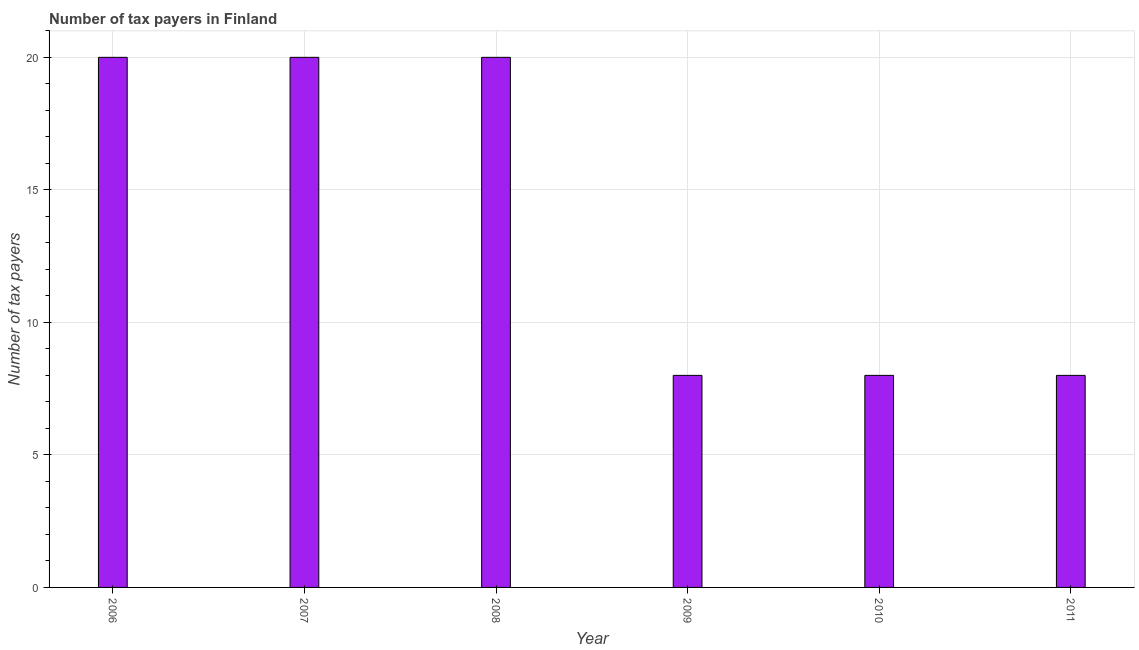Does the graph contain grids?
Your answer should be compact. Yes. What is the title of the graph?
Offer a terse response. Number of tax payers in Finland. What is the label or title of the X-axis?
Your answer should be very brief. Year. What is the label or title of the Y-axis?
Your answer should be very brief. Number of tax payers. Across all years, what is the maximum number of tax payers?
Offer a terse response. 20. Across all years, what is the minimum number of tax payers?
Your answer should be very brief. 8. In which year was the number of tax payers maximum?
Give a very brief answer. 2006. In which year was the number of tax payers minimum?
Your answer should be compact. 2009. What is the sum of the number of tax payers?
Provide a short and direct response. 84. What is the average number of tax payers per year?
Provide a succinct answer. 14. In how many years, is the number of tax payers greater than 17 ?
Give a very brief answer. 3. Do a majority of the years between 2007 and 2010 (inclusive) have number of tax payers greater than 10 ?
Offer a very short reply. No. What is the ratio of the number of tax payers in 2007 to that in 2009?
Your answer should be compact. 2.5. Is the number of tax payers in 2009 less than that in 2010?
Ensure brevity in your answer.  No. Is the difference between the number of tax payers in 2009 and 2011 greater than the difference between any two years?
Your answer should be compact. No. What is the difference between the highest and the second highest number of tax payers?
Provide a succinct answer. 0. Is the sum of the number of tax payers in 2008 and 2009 greater than the maximum number of tax payers across all years?
Provide a succinct answer. Yes. In how many years, is the number of tax payers greater than the average number of tax payers taken over all years?
Provide a short and direct response. 3. Are all the bars in the graph horizontal?
Keep it short and to the point. No. How many years are there in the graph?
Provide a succinct answer. 6. What is the difference between two consecutive major ticks on the Y-axis?
Offer a terse response. 5. Are the values on the major ticks of Y-axis written in scientific E-notation?
Give a very brief answer. No. What is the Number of tax payers of 2006?
Keep it short and to the point. 20. What is the Number of tax payers of 2008?
Make the answer very short. 20. What is the Number of tax payers of 2009?
Make the answer very short. 8. What is the Number of tax payers in 2011?
Offer a terse response. 8. What is the difference between the Number of tax payers in 2006 and 2008?
Offer a very short reply. 0. What is the difference between the Number of tax payers in 2006 and 2009?
Provide a short and direct response. 12. What is the difference between the Number of tax payers in 2007 and 2008?
Provide a short and direct response. 0. What is the difference between the Number of tax payers in 2007 and 2010?
Ensure brevity in your answer.  12. What is the difference between the Number of tax payers in 2008 and 2009?
Provide a succinct answer. 12. What is the difference between the Number of tax payers in 2008 and 2010?
Make the answer very short. 12. What is the difference between the Number of tax payers in 2009 and 2010?
Your answer should be compact. 0. What is the difference between the Number of tax payers in 2010 and 2011?
Give a very brief answer. 0. What is the ratio of the Number of tax payers in 2006 to that in 2007?
Ensure brevity in your answer.  1. What is the ratio of the Number of tax payers in 2007 to that in 2008?
Give a very brief answer. 1. What is the ratio of the Number of tax payers in 2007 to that in 2009?
Provide a succinct answer. 2.5. What is the ratio of the Number of tax payers in 2007 to that in 2011?
Make the answer very short. 2.5. What is the ratio of the Number of tax payers in 2008 to that in 2009?
Provide a succinct answer. 2.5. What is the ratio of the Number of tax payers in 2008 to that in 2011?
Provide a succinct answer. 2.5. What is the ratio of the Number of tax payers in 2009 to that in 2010?
Offer a terse response. 1. 